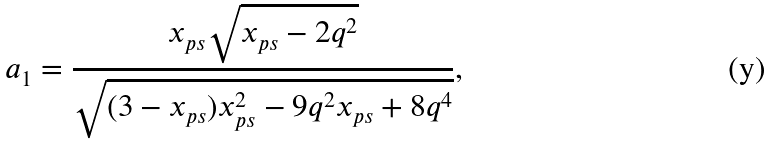<formula> <loc_0><loc_0><loc_500><loc_500>a _ { 1 } = \frac { x _ { p s } \sqrt { x _ { p s } - 2 q ^ { 2 } } } { \sqrt { ( 3 - x _ { p s } ) x ^ { 2 } _ { p s } - 9 q ^ { 2 } x _ { p s } + 8 q ^ { 4 } } } ,</formula> 